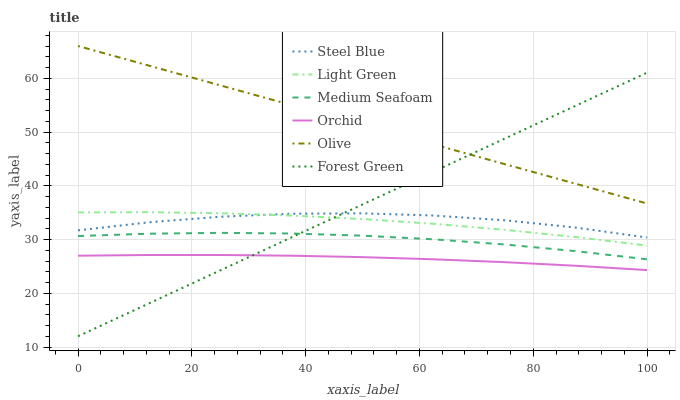Does Orchid have the minimum area under the curve?
Answer yes or no. Yes. Does Olive have the maximum area under the curve?
Answer yes or no. Yes. Does Forest Green have the minimum area under the curve?
Answer yes or no. No. Does Forest Green have the maximum area under the curve?
Answer yes or no. No. Is Forest Green the smoothest?
Answer yes or no. Yes. Is Steel Blue the roughest?
Answer yes or no. Yes. Is Light Green the smoothest?
Answer yes or no. No. Is Light Green the roughest?
Answer yes or no. No. Does Forest Green have the lowest value?
Answer yes or no. Yes. Does Light Green have the lowest value?
Answer yes or no. No. Does Olive have the highest value?
Answer yes or no. Yes. Does Forest Green have the highest value?
Answer yes or no. No. Is Medium Seafoam less than Steel Blue?
Answer yes or no. Yes. Is Olive greater than Light Green?
Answer yes or no. Yes. Does Light Green intersect Forest Green?
Answer yes or no. Yes. Is Light Green less than Forest Green?
Answer yes or no. No. Is Light Green greater than Forest Green?
Answer yes or no. No. Does Medium Seafoam intersect Steel Blue?
Answer yes or no. No. 